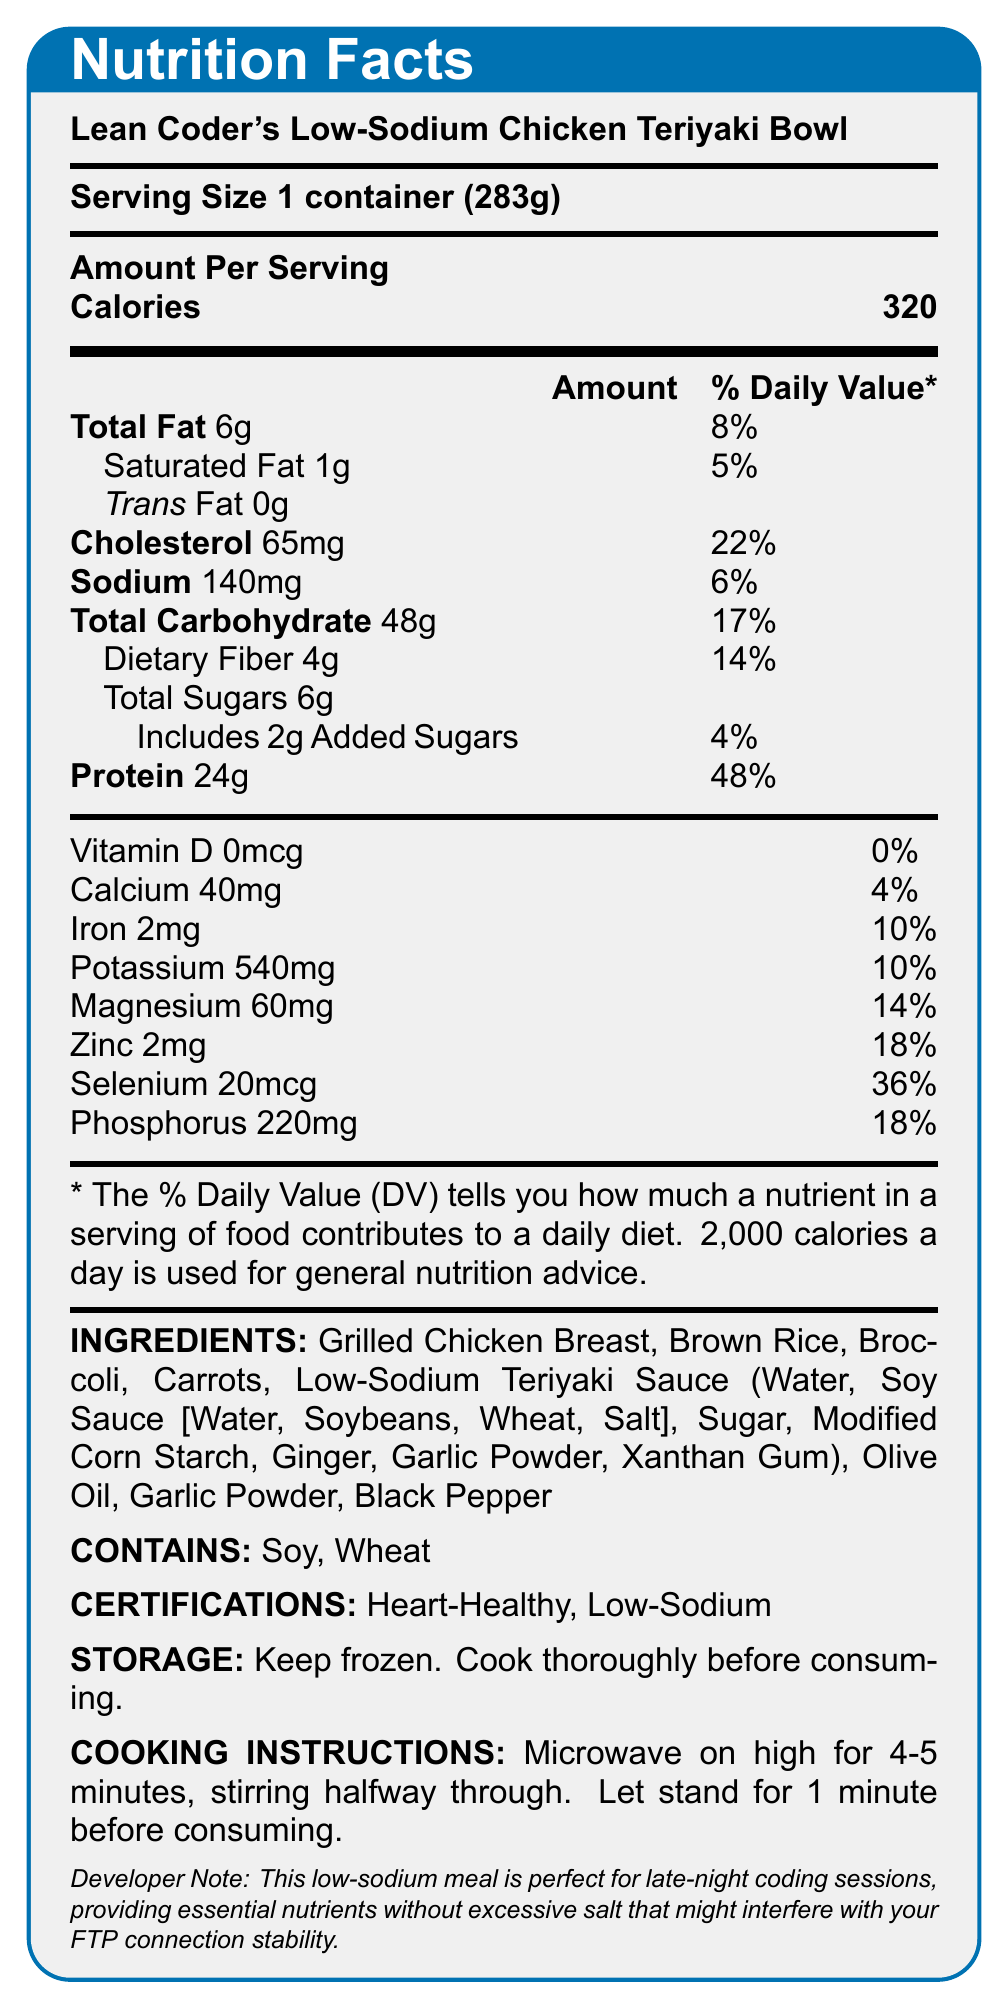What is the serving size of Lean Coder's Low-Sodium Chicken Teriyaki Bowl? The serving size is clearly marked as "1 container (283g)" in the document.
Answer: 1 container (283g) How many calories are there per serving? The document states that each serving contains 320 calories.
Answer: 320 How much cholesterol is in one serving, and what is its % Daily Value? The document lists cholesterol content as 65 mg and its % Daily Value as 22%.
Answer: 65 mg, 22% What are the ingredients of the low-sodium teriyaki sauce used in this meal? The ingredients for the low-sodium teriyaki sauce are listed in detail within the ingredients section.
Answer: Water, Soy Sauce (Water, Soybeans, Wheat, Salt), Sugar, Modified Corn Starch, Ginger, Garlic Powder, Xanthan Gum How much protein does this meal provide, and what is its % Daily Value? The protein content is 24g, which is 48% of the Daily Value.
Answer: 24g, 48% Which of the following is not listed as a certification for this meal? A. Gluten-Free B. Heart-Healthy C. Low-Sodium The document lists "Heart-Healthy" and "Low-Sodium" as certifications, but not "Gluten-Free".
Answer: A Is the meal suitable for someone with a soy allergy? The document clearly states that the meal contains soy, making it unsuitable for someone with a soy allergy.
Answer: No Summarize the nutrition and health aspects of Lean Coder's Low-Sodium Chicken Teriyaki Bowl. The document provides comprehensive nutritional information, ingredients, and instructions, emphasizing the meal's health benefits and ease of preparation.
Answer: Lean Coder's Low-Sodium Chicken Teriyaki Bowl is a nutritious frozen meal with 320 calories per serving. It provides 24g of protein, 6g total fat (1g saturated fat), 140mg sodium, 48g total carbohydrates (4g dietary fiber and 6g total sugars, including 2g added sugars). It contains essential minerals and vitamins, including calcium, iron, potassium, magnesium, zinc, selenium, and phosphorus. Packaged with ingredients like grilled chicken breast, brown rice, and low-sodium teriyaki sauce, it is certified Heart-Healthy and Low-Sodium, making it suitable for individuals mindful of their sodium intake. The meal is easy to prepare in the microwave and is designed to support late-night coding sessions. What is the carbon footprint of Lean Coder's Low-Sodium Chicken Teriyaki Bowl? The document does not provide any information related to the carbon footprint or environmental impact of the meal.
Answer: Not enough information 